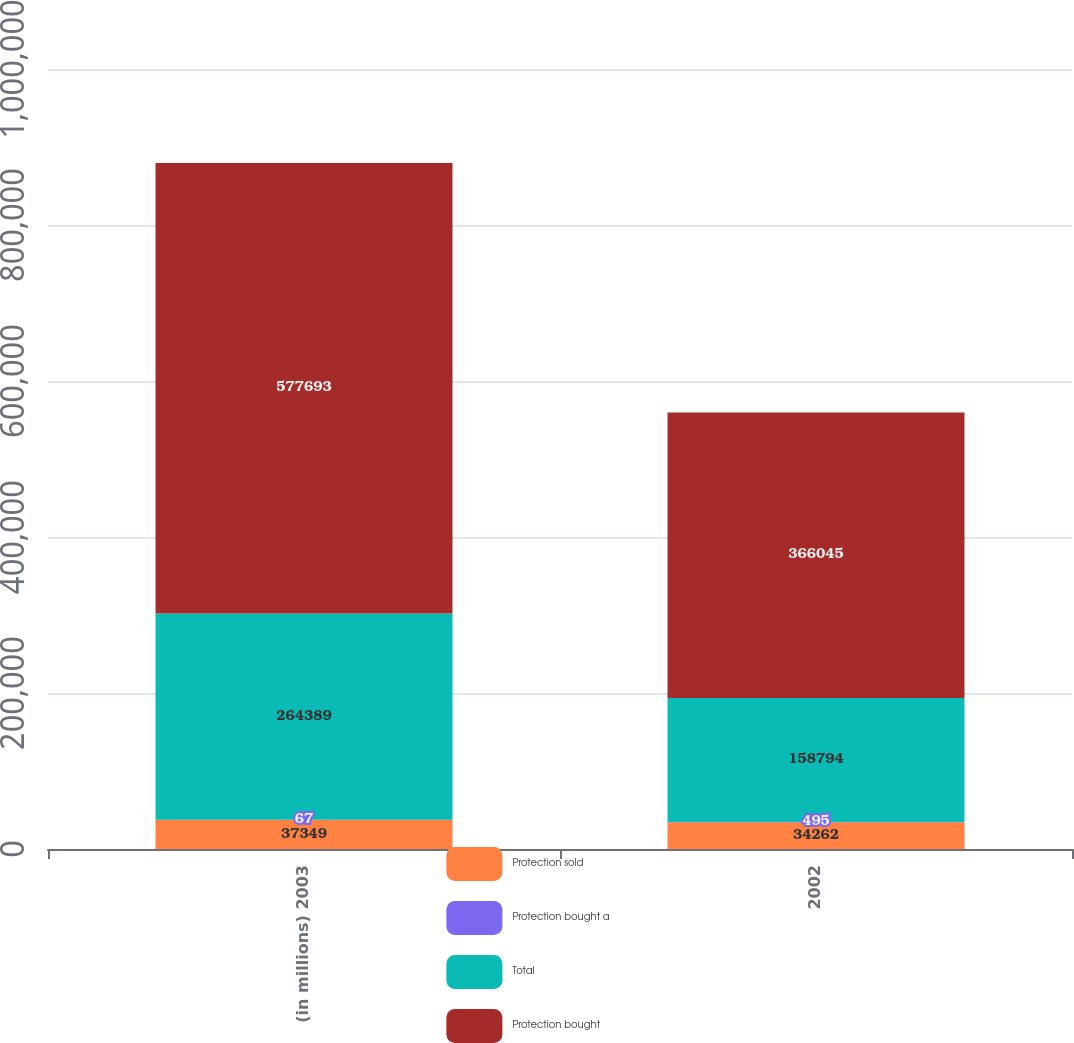<chart> <loc_0><loc_0><loc_500><loc_500><stacked_bar_chart><ecel><fcel>(in millions) 2003<fcel>2002<nl><fcel>Protection sold<fcel>37349<fcel>34262<nl><fcel>Protection bought a<fcel>67<fcel>495<nl><fcel>Total<fcel>264389<fcel>158794<nl><fcel>Protection bought<fcel>577693<fcel>366045<nl></chart> 